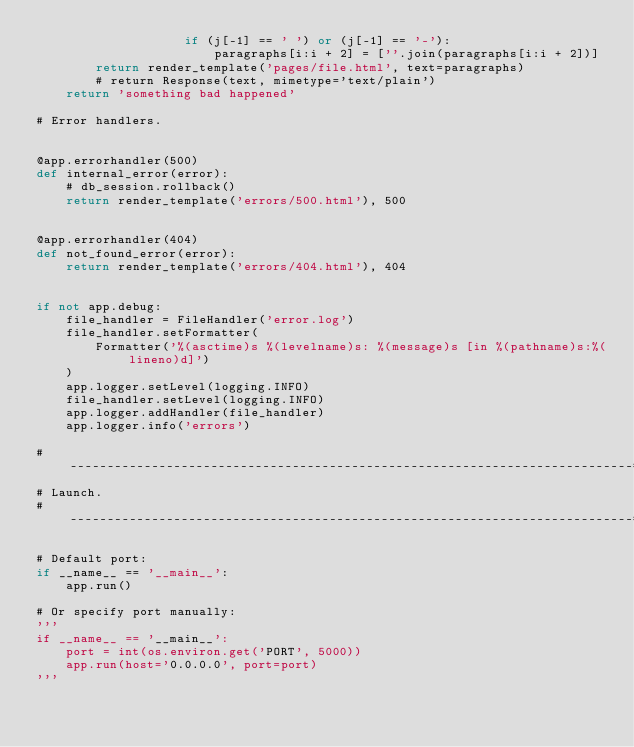Convert code to text. <code><loc_0><loc_0><loc_500><loc_500><_Python_>                    if (j[-1] == ' ') or (j[-1] == '-'):
                        paragraphs[i:i + 2] = [''.join(paragraphs[i:i + 2])]
        return render_template('pages/file.html', text=paragraphs)
        # return Response(text, mimetype='text/plain')
    return 'something bad happened'

# Error handlers.


@app.errorhandler(500)
def internal_error(error):
    # db_session.rollback()
    return render_template('errors/500.html'), 500


@app.errorhandler(404)
def not_found_error(error):
    return render_template('errors/404.html'), 404


if not app.debug:
    file_handler = FileHandler('error.log')
    file_handler.setFormatter(
        Formatter('%(asctime)s %(levelname)s: %(message)s [in %(pathname)s:%(lineno)d]')
    )
    app.logger.setLevel(logging.INFO)
    file_handler.setLevel(logging.INFO)
    app.logger.addHandler(file_handler)
    app.logger.info('errors')

# ----------------------------------------------------------------------------#
# Launch.
# ----------------------------------------------------------------------------#

# Default port:
if __name__ == '__main__':
    app.run()

# Or specify port manually:
'''
if __name__ == '__main__':
    port = int(os.environ.get('PORT', 5000))
    app.run(host='0.0.0.0', port=port)
'''
</code> 